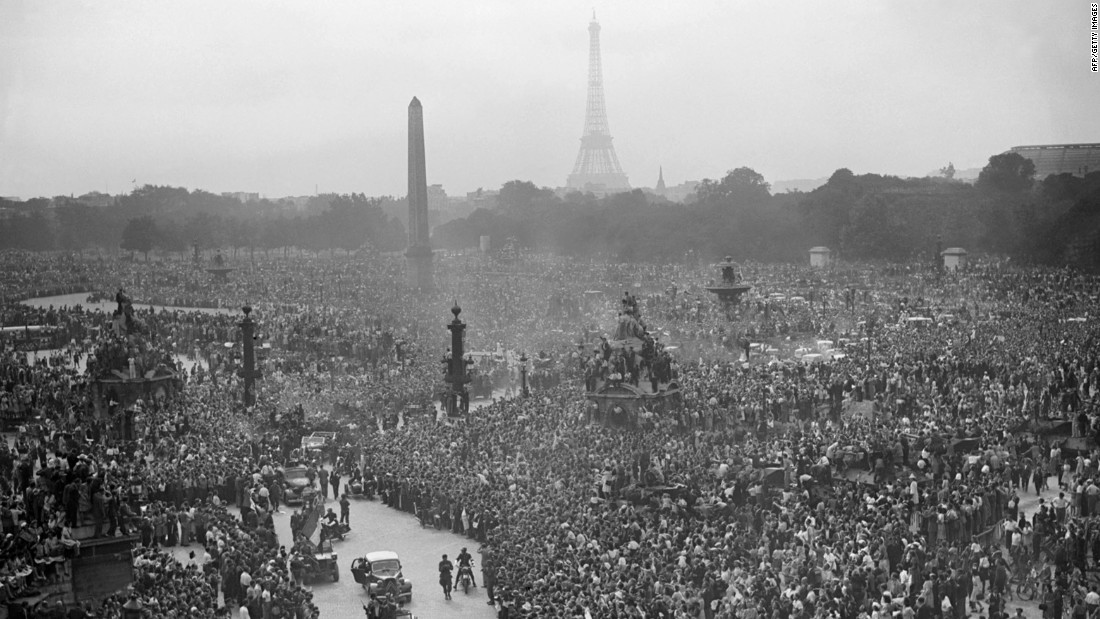Why do you think so many people have gathered at this specific location? The Place de la Concorde is a historically significant site in Paris, known for being the center of many important events. The vast number of people gathered here suggests that the event being celebrated has deep national importance, possibly a victory or liberation. This location, with its historical monuments and central prominence, makes it an apt gathering place for citizens to unite and celebrate a significant national achievement or commemoration. 